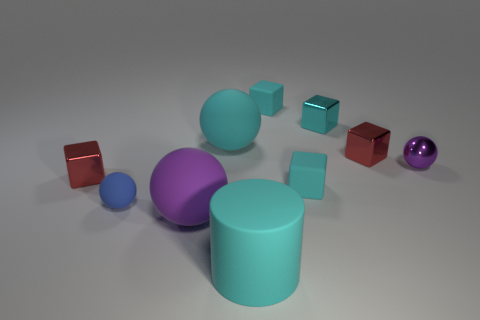Subtract all purple metal spheres. How many spheres are left? 3 Subtract all cyan spheres. How many cyan cubes are left? 3 Subtract all red blocks. How many blocks are left? 3 Subtract 1 balls. How many balls are left? 3 Subtract all balls. How many objects are left? 6 Subtract all brown cubes. Subtract all gray cylinders. How many cubes are left? 5 Subtract 0 blue blocks. How many objects are left? 10 Subtract all small blue spheres. Subtract all small yellow rubber balls. How many objects are left? 9 Add 5 large cyan balls. How many large cyan balls are left? 6 Add 6 cylinders. How many cylinders exist? 7 